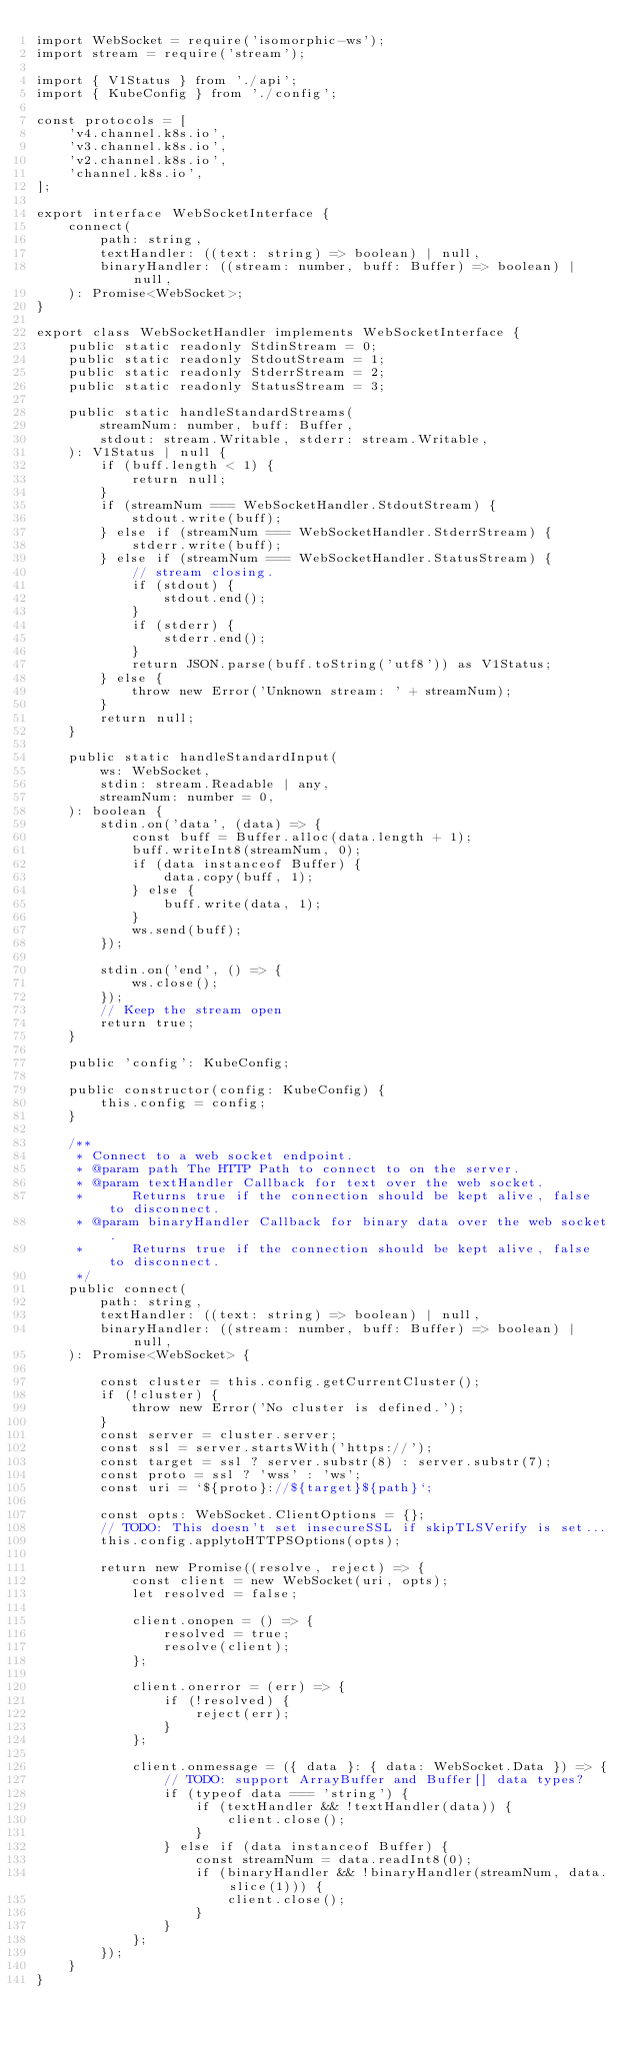Convert code to text. <code><loc_0><loc_0><loc_500><loc_500><_TypeScript_>import WebSocket = require('isomorphic-ws');
import stream = require('stream');

import { V1Status } from './api';
import { KubeConfig } from './config';

const protocols = [
    'v4.channel.k8s.io',
    'v3.channel.k8s.io',
    'v2.channel.k8s.io',
    'channel.k8s.io',
];

export interface WebSocketInterface {
    connect(
        path: string,
        textHandler: ((text: string) => boolean) | null,
        binaryHandler: ((stream: number, buff: Buffer) => boolean) | null,
    ): Promise<WebSocket>;
}

export class WebSocketHandler implements WebSocketInterface {
    public static readonly StdinStream = 0;
    public static readonly StdoutStream = 1;
    public static readonly StderrStream = 2;
    public static readonly StatusStream = 3;

    public static handleStandardStreams(
        streamNum: number, buff: Buffer,
        stdout: stream.Writable, stderr: stream.Writable,
    ): V1Status | null {
        if (buff.length < 1) {
            return null;
        }
        if (streamNum === WebSocketHandler.StdoutStream) {
            stdout.write(buff);
        } else if (streamNum === WebSocketHandler.StderrStream) {
            stderr.write(buff);
        } else if (streamNum === WebSocketHandler.StatusStream) {
            // stream closing.
            if (stdout) {
                stdout.end();
            }
            if (stderr) {
                stderr.end();
            }
            return JSON.parse(buff.toString('utf8')) as V1Status;
        } else {
            throw new Error('Unknown stream: ' + streamNum);
        }
        return null;
    }

    public static handleStandardInput(
        ws: WebSocket,
        stdin: stream.Readable | any,
        streamNum: number = 0,
    ): boolean {
        stdin.on('data', (data) => {
            const buff = Buffer.alloc(data.length + 1);
            buff.writeInt8(streamNum, 0);
            if (data instanceof Buffer) {
                data.copy(buff, 1);
            } else {
                buff.write(data, 1);
            }
            ws.send(buff);
        });

        stdin.on('end', () => {
            ws.close();
        });
        // Keep the stream open
        return true;
    }

    public 'config': KubeConfig;

    public constructor(config: KubeConfig) {
        this.config = config;
    }

    /**
     * Connect to a web socket endpoint.
     * @param path The HTTP Path to connect to on the server.
     * @param textHandler Callback for text over the web socket.
     *      Returns true if the connection should be kept alive, false to disconnect.
     * @param binaryHandler Callback for binary data over the web socket.
     *      Returns true if the connection should be kept alive, false to disconnect.
     */
    public connect(
        path: string,
        textHandler: ((text: string) => boolean) | null,
        binaryHandler: ((stream: number, buff: Buffer) => boolean) | null,
    ): Promise<WebSocket> {

        const cluster = this.config.getCurrentCluster();
        if (!cluster) {
            throw new Error('No cluster is defined.');
        }
        const server = cluster.server;
        const ssl = server.startsWith('https://');
        const target = ssl ? server.substr(8) : server.substr(7);
        const proto = ssl ? 'wss' : 'ws';
        const uri = `${proto}://${target}${path}`;

        const opts: WebSocket.ClientOptions = {};
        // TODO: This doesn't set insecureSSL if skipTLSVerify is set...
        this.config.applytoHTTPSOptions(opts);

        return new Promise((resolve, reject) => {
            const client = new WebSocket(uri, opts);
            let resolved = false;

            client.onopen = () => {
                resolved = true;
                resolve(client);
            };

            client.onerror = (err) => {
                if (!resolved) {
                    reject(err);
                }
            };

            client.onmessage = ({ data }: { data: WebSocket.Data }) => {
                // TODO: support ArrayBuffer and Buffer[] data types?
                if (typeof data === 'string') {
                    if (textHandler && !textHandler(data)) {
                        client.close();
                    }
                } else if (data instanceof Buffer) {
                    const streamNum = data.readInt8(0);
                    if (binaryHandler && !binaryHandler(streamNum, data.slice(1))) {
                        client.close();
                    }
                }
            };
        });
    }
}
</code> 